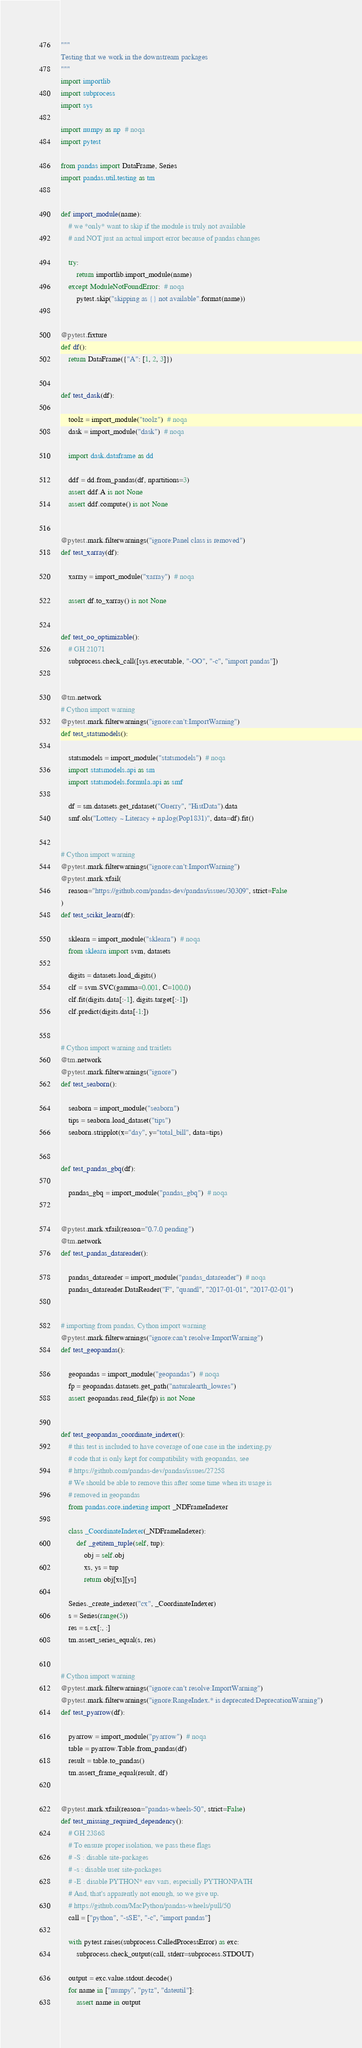<code> <loc_0><loc_0><loc_500><loc_500><_Python_>"""
Testing that we work in the downstream packages
"""
import importlib
import subprocess
import sys

import numpy as np  # noqa
import pytest

from pandas import DataFrame, Series
import pandas.util.testing as tm


def import_module(name):
    # we *only* want to skip if the module is truly not available
    # and NOT just an actual import error because of pandas changes

    try:
        return importlib.import_module(name)
    except ModuleNotFoundError:  # noqa
        pytest.skip("skipping as {} not available".format(name))


@pytest.fixture
def df():
    return DataFrame({"A": [1, 2, 3]})


def test_dask(df):

    toolz = import_module("toolz")  # noqa
    dask = import_module("dask")  # noqa

    import dask.dataframe as dd

    ddf = dd.from_pandas(df, npartitions=3)
    assert ddf.A is not None
    assert ddf.compute() is not None


@pytest.mark.filterwarnings("ignore:Panel class is removed")
def test_xarray(df):

    xarray = import_module("xarray")  # noqa

    assert df.to_xarray() is not None


def test_oo_optimizable():
    # GH 21071
    subprocess.check_call([sys.executable, "-OO", "-c", "import pandas"])


@tm.network
# Cython import warning
@pytest.mark.filterwarnings("ignore:can't:ImportWarning")
def test_statsmodels():

    statsmodels = import_module("statsmodels")  # noqa
    import statsmodels.api as sm
    import statsmodels.formula.api as smf

    df = sm.datasets.get_rdataset("Guerry", "HistData").data
    smf.ols("Lottery ~ Literacy + np.log(Pop1831)", data=df).fit()


# Cython import warning
@pytest.mark.filterwarnings("ignore:can't:ImportWarning")
@pytest.mark.xfail(
    reason="https://github.com/pandas-dev/pandas/issues/30309", strict=False
)
def test_scikit_learn(df):

    sklearn = import_module("sklearn")  # noqa
    from sklearn import svm, datasets

    digits = datasets.load_digits()
    clf = svm.SVC(gamma=0.001, C=100.0)
    clf.fit(digits.data[:-1], digits.target[:-1])
    clf.predict(digits.data[-1:])


# Cython import warning and traitlets
@tm.network
@pytest.mark.filterwarnings("ignore")
def test_seaborn():

    seaborn = import_module("seaborn")
    tips = seaborn.load_dataset("tips")
    seaborn.stripplot(x="day", y="total_bill", data=tips)


def test_pandas_gbq(df):

    pandas_gbq = import_module("pandas_gbq")  # noqa


@pytest.mark.xfail(reason="0.7.0 pending")
@tm.network
def test_pandas_datareader():

    pandas_datareader = import_module("pandas_datareader")  # noqa
    pandas_datareader.DataReader("F", "quandl", "2017-01-01", "2017-02-01")


# importing from pandas, Cython import warning
@pytest.mark.filterwarnings("ignore:can't resolve:ImportWarning")
def test_geopandas():

    geopandas = import_module("geopandas")  # noqa
    fp = geopandas.datasets.get_path("naturalearth_lowres")
    assert geopandas.read_file(fp) is not None


def test_geopandas_coordinate_indexer():
    # this test is included to have coverage of one case in the indexing.py
    # code that is only kept for compatibility with geopandas, see
    # https://github.com/pandas-dev/pandas/issues/27258
    # We should be able to remove this after some time when its usage is
    # removed in geopandas
    from pandas.core.indexing import _NDFrameIndexer

    class _CoordinateIndexer(_NDFrameIndexer):
        def _getitem_tuple(self, tup):
            obj = self.obj
            xs, ys = tup
            return obj[xs][ys]

    Series._create_indexer("cx", _CoordinateIndexer)
    s = Series(range(5))
    res = s.cx[:, :]
    tm.assert_series_equal(s, res)


# Cython import warning
@pytest.mark.filterwarnings("ignore:can't resolve:ImportWarning")
@pytest.mark.filterwarnings("ignore:RangeIndex.* is deprecated:DeprecationWarning")
def test_pyarrow(df):

    pyarrow = import_module("pyarrow")  # noqa
    table = pyarrow.Table.from_pandas(df)
    result = table.to_pandas()
    tm.assert_frame_equal(result, df)


@pytest.mark.xfail(reason="pandas-wheels-50", strict=False)
def test_missing_required_dependency():
    # GH 23868
    # To ensure proper isolation, we pass these flags
    # -S : disable site-packages
    # -s : disable user site-packages
    # -E : disable PYTHON* env vars, especially PYTHONPATH
    # And, that's apparently not enough, so we give up.
    # https://github.com/MacPython/pandas-wheels/pull/50
    call = ["python", "-sSE", "-c", "import pandas"]

    with pytest.raises(subprocess.CalledProcessError) as exc:
        subprocess.check_output(call, stderr=subprocess.STDOUT)

    output = exc.value.stdout.decode()
    for name in ["numpy", "pytz", "dateutil"]:
        assert name in output
</code> 